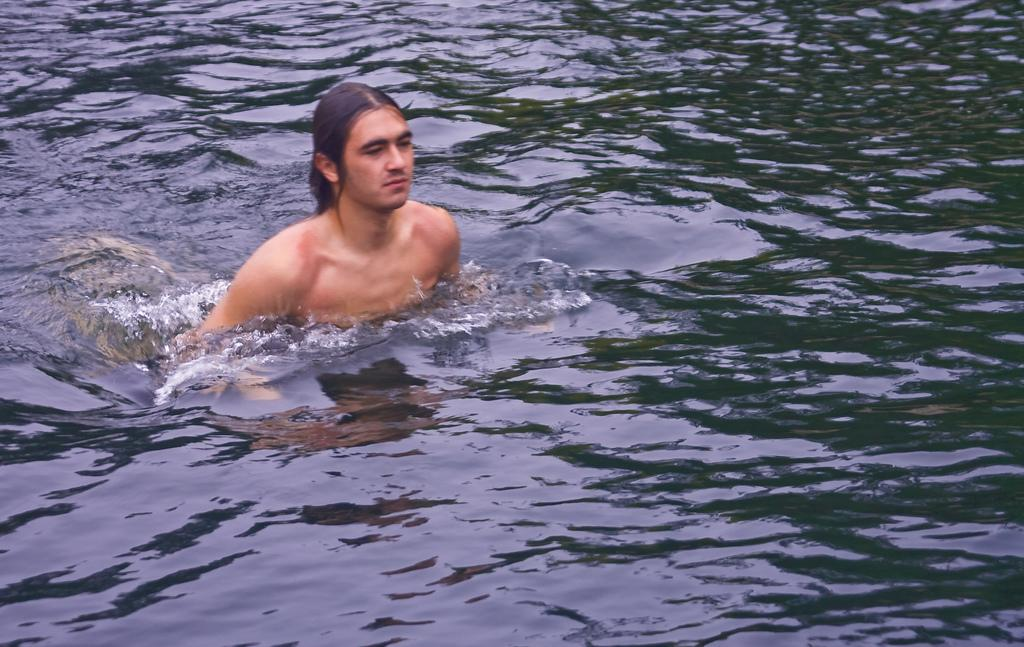Who is present in the image? There is a person in the image. What is the person doing in the image? The person is bathing in water. What type of lumber is being used to grip the donkey in the image? There is no lumber or donkey present in the image; it only features a person bathing in water. 